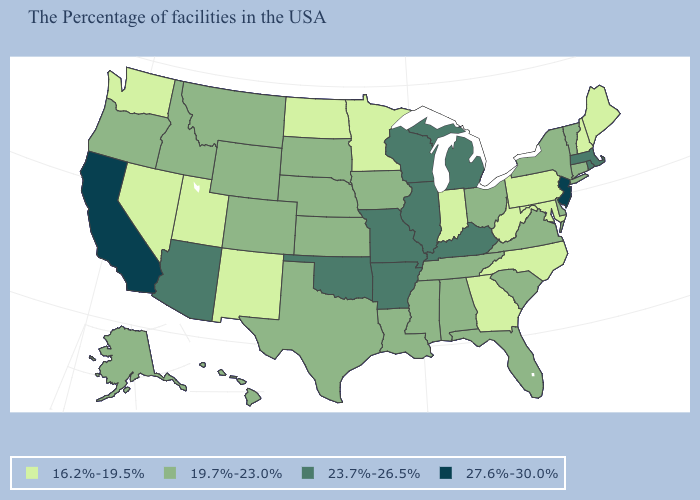Name the states that have a value in the range 16.2%-19.5%?
Write a very short answer. Maine, New Hampshire, Maryland, Pennsylvania, North Carolina, West Virginia, Georgia, Indiana, Minnesota, North Dakota, New Mexico, Utah, Nevada, Washington. What is the value of Alabama?
Answer briefly. 19.7%-23.0%. What is the value of California?
Answer briefly. 27.6%-30.0%. What is the value of Vermont?
Quick response, please. 19.7%-23.0%. Does Arizona have the highest value in the West?
Quick response, please. No. Which states hav the highest value in the MidWest?
Give a very brief answer. Michigan, Wisconsin, Illinois, Missouri. Name the states that have a value in the range 23.7%-26.5%?
Give a very brief answer. Massachusetts, Rhode Island, Michigan, Kentucky, Wisconsin, Illinois, Missouri, Arkansas, Oklahoma, Arizona. What is the value of Virginia?
Quick response, please. 19.7%-23.0%. Name the states that have a value in the range 23.7%-26.5%?
Quick response, please. Massachusetts, Rhode Island, Michigan, Kentucky, Wisconsin, Illinois, Missouri, Arkansas, Oklahoma, Arizona. What is the highest value in the USA?
Be succinct. 27.6%-30.0%. Name the states that have a value in the range 19.7%-23.0%?
Quick response, please. Vermont, Connecticut, New York, Delaware, Virginia, South Carolina, Ohio, Florida, Alabama, Tennessee, Mississippi, Louisiana, Iowa, Kansas, Nebraska, Texas, South Dakota, Wyoming, Colorado, Montana, Idaho, Oregon, Alaska, Hawaii. Name the states that have a value in the range 16.2%-19.5%?
Keep it brief. Maine, New Hampshire, Maryland, Pennsylvania, North Carolina, West Virginia, Georgia, Indiana, Minnesota, North Dakota, New Mexico, Utah, Nevada, Washington. Does New York have a lower value than New Mexico?
Give a very brief answer. No. Does Alaska have a higher value than Washington?
Be succinct. Yes. Name the states that have a value in the range 27.6%-30.0%?
Write a very short answer. New Jersey, California. 